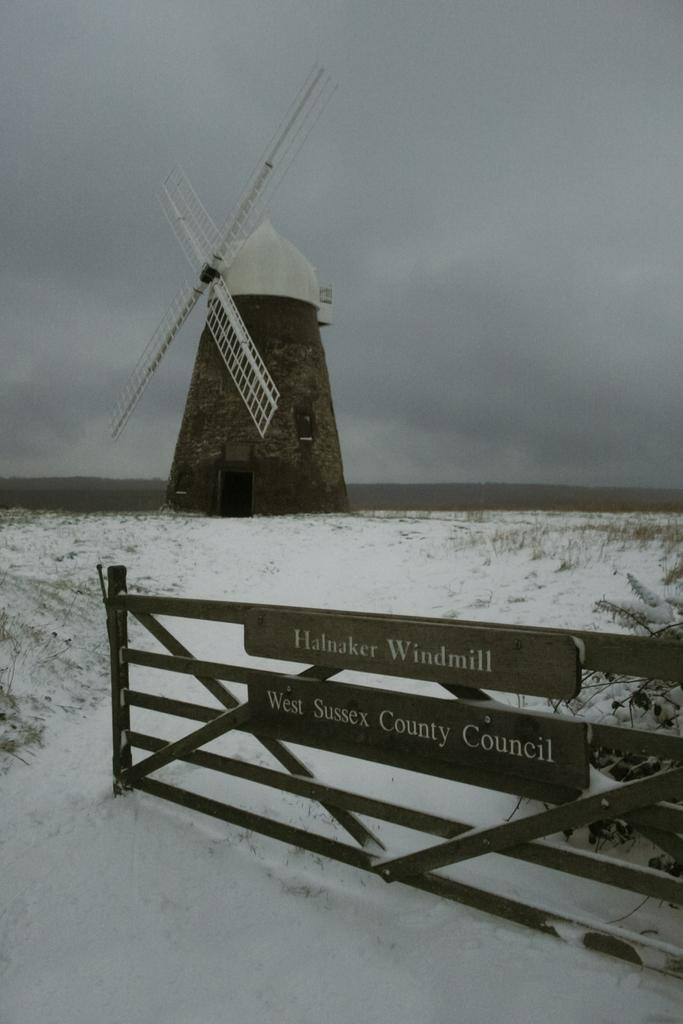What is the main structure visible in the image? There is a windmill in the image. What is located in front of the windmill? There is a wooden fence in front of the windmill. What type of weather condition is depicted in the image? There is snow on the surface in the image. What type of company is operating the windmill in the image? There is no indication of a company operating the windmill in the image. What type of berry can be seen growing on the windmill in the image? There are no berries present on the windmill in the image. 